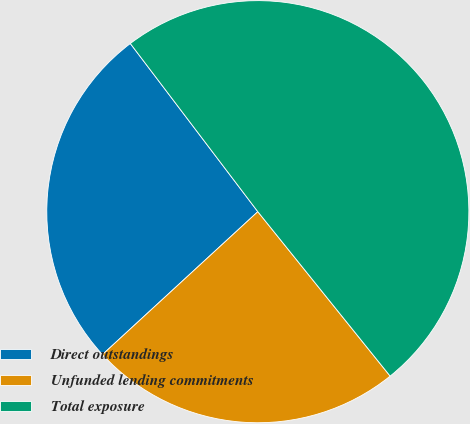Convert chart. <chart><loc_0><loc_0><loc_500><loc_500><pie_chart><fcel>Direct outstandings<fcel>Unfunded lending commitments<fcel>Total exposure<nl><fcel>26.51%<fcel>23.95%<fcel>49.54%<nl></chart> 